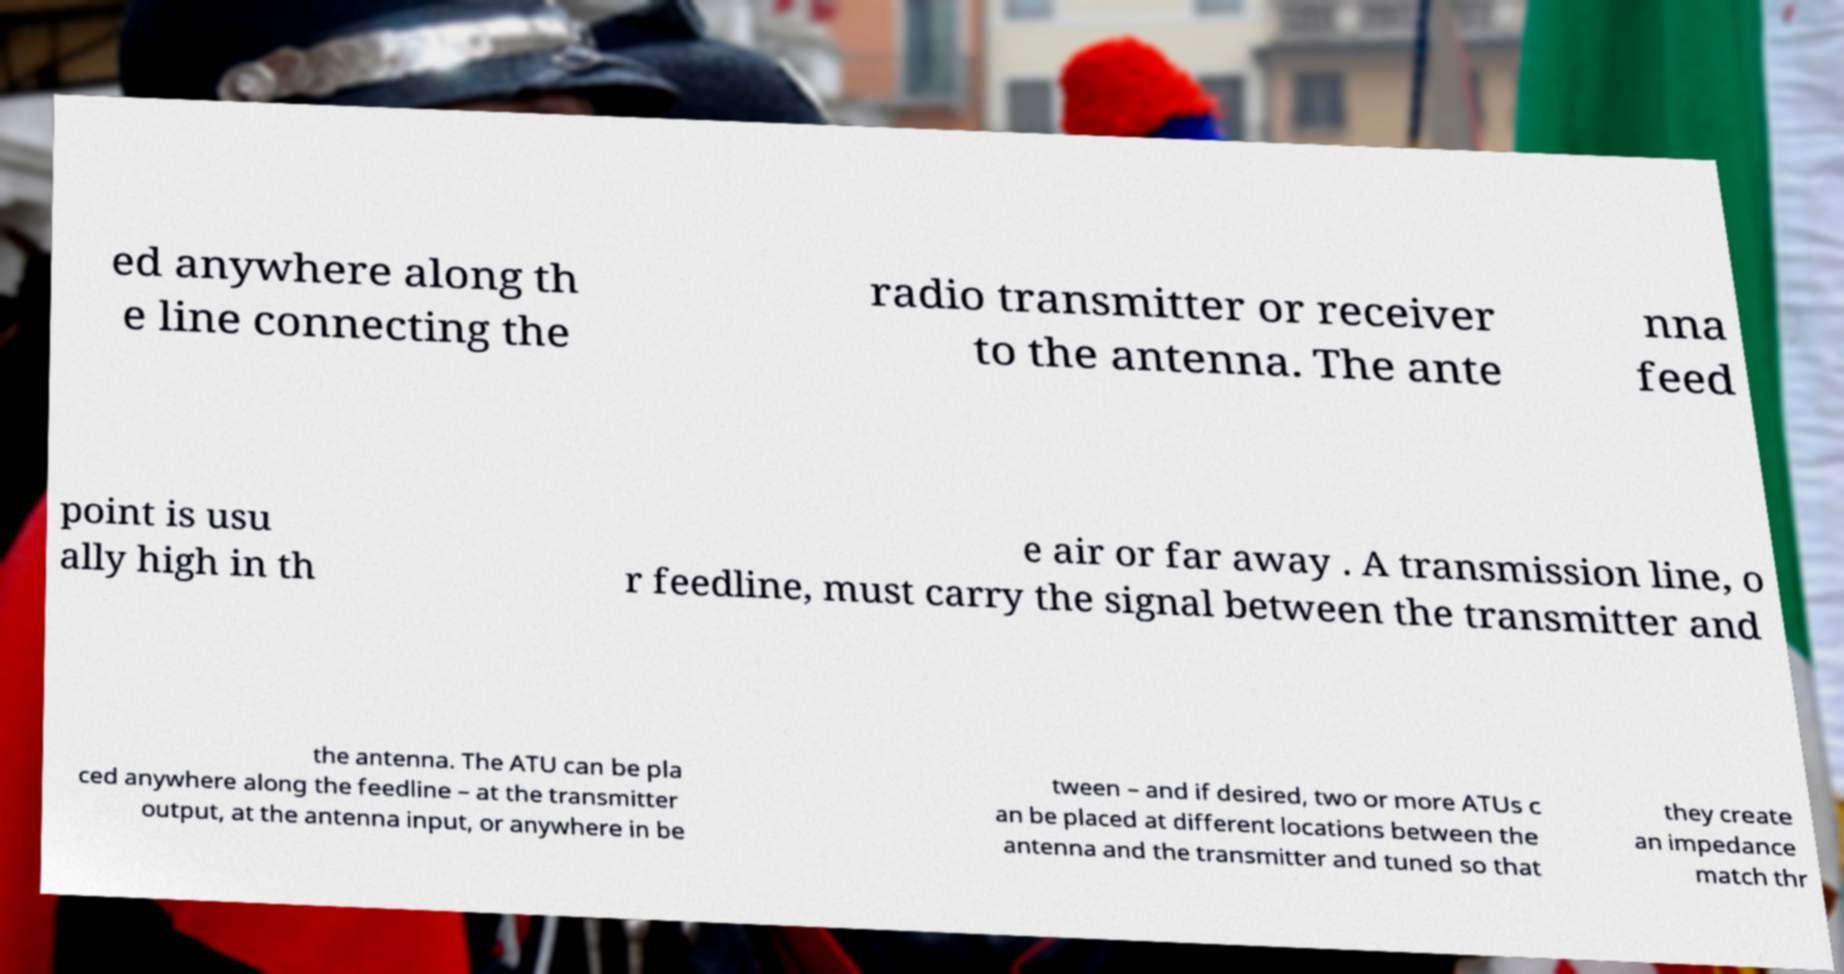There's text embedded in this image that I need extracted. Can you transcribe it verbatim? ed anywhere along th e line connecting the radio transmitter or receiver to the antenna. The ante nna feed point is usu ally high in th e air or far away . A transmission line, o r feedline, must carry the signal between the transmitter and the antenna. The ATU can be pla ced anywhere along the feedline – at the transmitter output, at the antenna input, or anywhere in be tween – and if desired, two or more ATUs c an be placed at different locations between the antenna and the transmitter and tuned so that they create an impedance match thr 